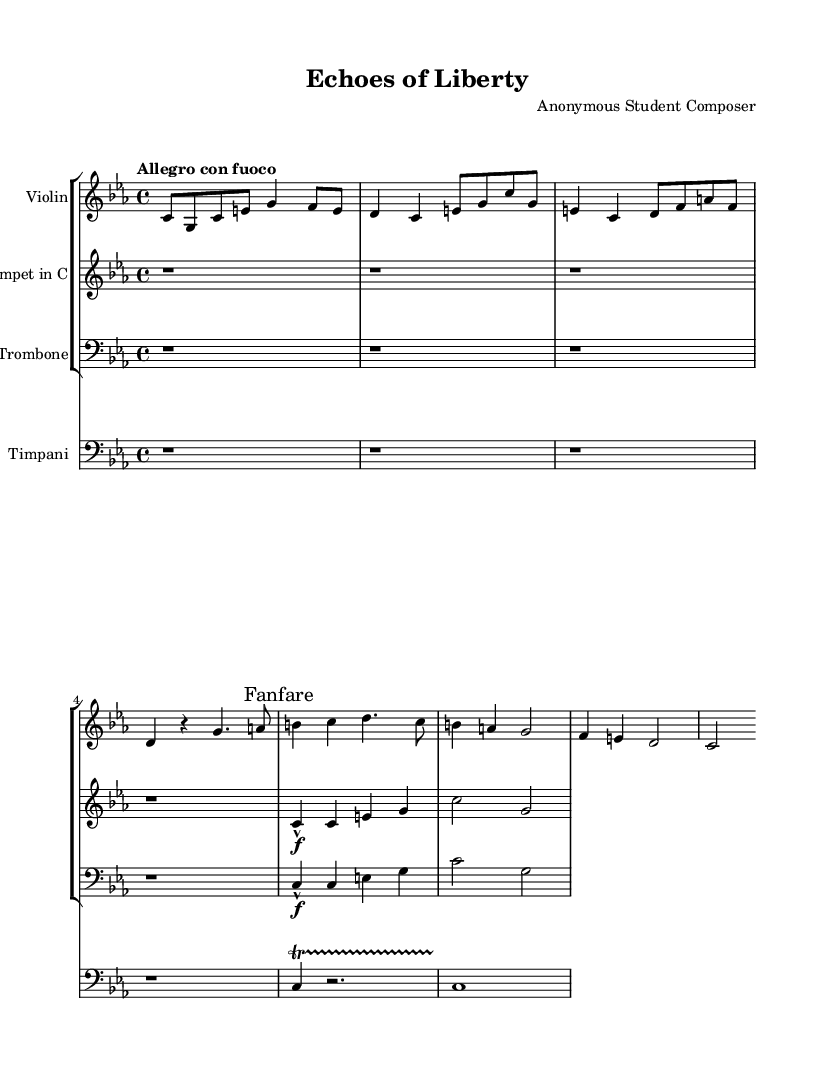What is the key signature of this music? The key signature is C minor, which has three flats (B flat, E flat, and A flat). You can see the key signature at the beginning of the staff before the time signature.
Answer: C minor What is the time signature of this music? The time signature is 4/4, which indicates there are four beats in a measure, and the quarter note gets one beat. This can be found next to the key signature at the beginning of the score.
Answer: 4/4 What is the tempo marking for this symphony? The tempo marking is "Allegro con fuoco," indicating a fast tempo with fire or passion. The tempo indication is placed directly above the global settings, guiding the performers on how swiftly to play the piece.
Answer: Allegro con fuoco Which instrument plays the main theme first? The main theme is first played by the violin, as indicated by its part directly following the global settings section, showcasing the primary melodic line.
Answer: Violin What dynamics are indicated for the trumpet's fanfare? The dynamics indicated for the trumpet's fanfare are forte, which is symbolized by the marking "f" above the notes. This shows that the passage should be played loudly.
Answer: Forte How many beats does the trombone's first measure have? The trombone's first measure has four beats, as indicated by the time signature of 4/4 and the presence of four quarter notes in that measure. Counting the beats gives a total of four.
Answer: Four 